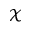Convert formula to latex. <formula><loc_0><loc_0><loc_500><loc_500>\mathcal { X }</formula> 